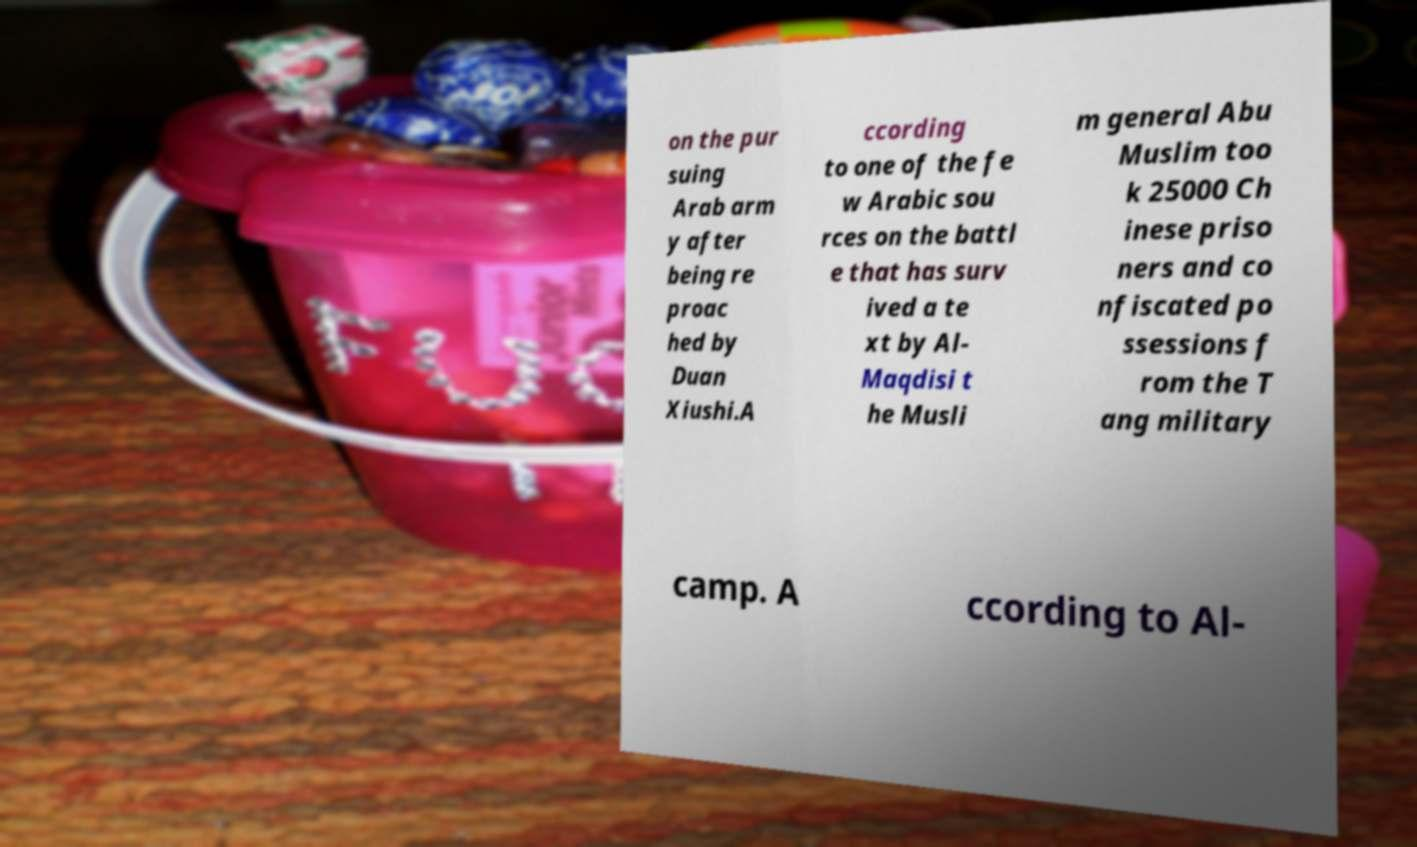Could you extract and type out the text from this image? on the pur suing Arab arm y after being re proac hed by Duan Xiushi.A ccording to one of the fe w Arabic sou rces on the battl e that has surv ived a te xt by Al- Maqdisi t he Musli m general Abu Muslim too k 25000 Ch inese priso ners and co nfiscated po ssessions f rom the T ang military camp. A ccording to Al- 